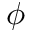Convert formula to latex. <formula><loc_0><loc_0><loc_500><loc_500>\phi</formula> 